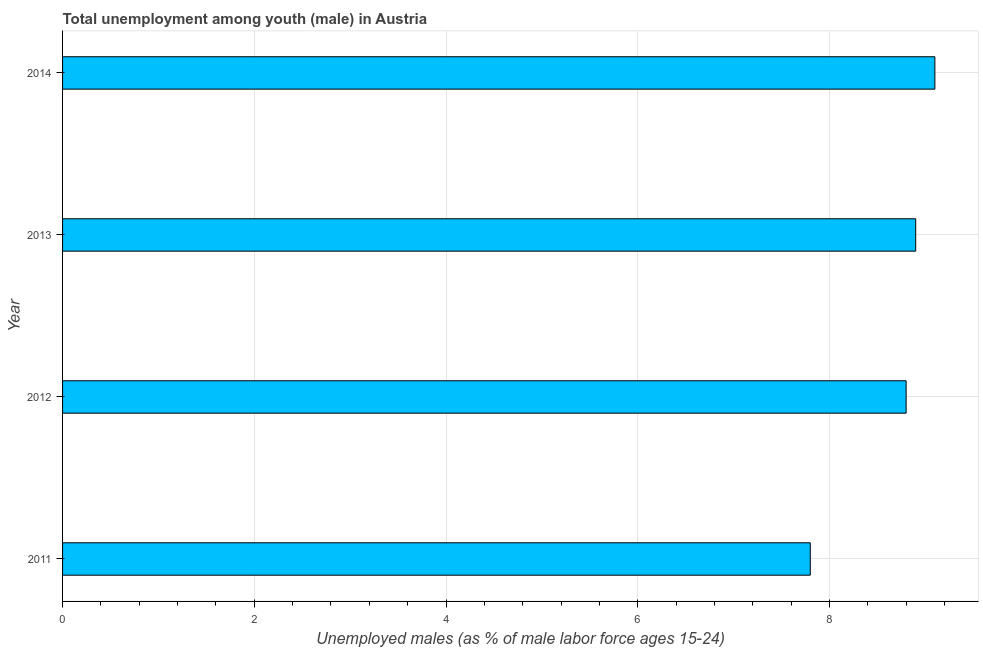Does the graph contain grids?
Offer a very short reply. Yes. What is the title of the graph?
Make the answer very short. Total unemployment among youth (male) in Austria. What is the label or title of the X-axis?
Offer a very short reply. Unemployed males (as % of male labor force ages 15-24). What is the unemployed male youth population in 2014?
Ensure brevity in your answer.  9.1. Across all years, what is the maximum unemployed male youth population?
Offer a very short reply. 9.1. Across all years, what is the minimum unemployed male youth population?
Keep it short and to the point. 7.8. In which year was the unemployed male youth population maximum?
Your answer should be very brief. 2014. What is the sum of the unemployed male youth population?
Provide a succinct answer. 34.6. What is the difference between the unemployed male youth population in 2012 and 2013?
Your answer should be very brief. -0.1. What is the average unemployed male youth population per year?
Your response must be concise. 8.65. What is the median unemployed male youth population?
Your answer should be compact. 8.85. In how many years, is the unemployed male youth population greater than 1.2 %?
Make the answer very short. 4. What is the ratio of the unemployed male youth population in 2013 to that in 2014?
Offer a terse response. 0.98. How many bars are there?
Your answer should be very brief. 4. How many years are there in the graph?
Your response must be concise. 4. What is the difference between two consecutive major ticks on the X-axis?
Offer a very short reply. 2. Are the values on the major ticks of X-axis written in scientific E-notation?
Ensure brevity in your answer.  No. What is the Unemployed males (as % of male labor force ages 15-24) in 2011?
Ensure brevity in your answer.  7.8. What is the Unemployed males (as % of male labor force ages 15-24) in 2012?
Your answer should be very brief. 8.8. What is the Unemployed males (as % of male labor force ages 15-24) of 2013?
Offer a very short reply. 8.9. What is the Unemployed males (as % of male labor force ages 15-24) of 2014?
Give a very brief answer. 9.1. What is the difference between the Unemployed males (as % of male labor force ages 15-24) in 2011 and 2013?
Make the answer very short. -1.1. What is the difference between the Unemployed males (as % of male labor force ages 15-24) in 2011 and 2014?
Provide a short and direct response. -1.3. What is the ratio of the Unemployed males (as % of male labor force ages 15-24) in 2011 to that in 2012?
Keep it short and to the point. 0.89. What is the ratio of the Unemployed males (as % of male labor force ages 15-24) in 2011 to that in 2013?
Ensure brevity in your answer.  0.88. What is the ratio of the Unemployed males (as % of male labor force ages 15-24) in 2011 to that in 2014?
Your answer should be very brief. 0.86. What is the ratio of the Unemployed males (as % of male labor force ages 15-24) in 2013 to that in 2014?
Offer a terse response. 0.98. 